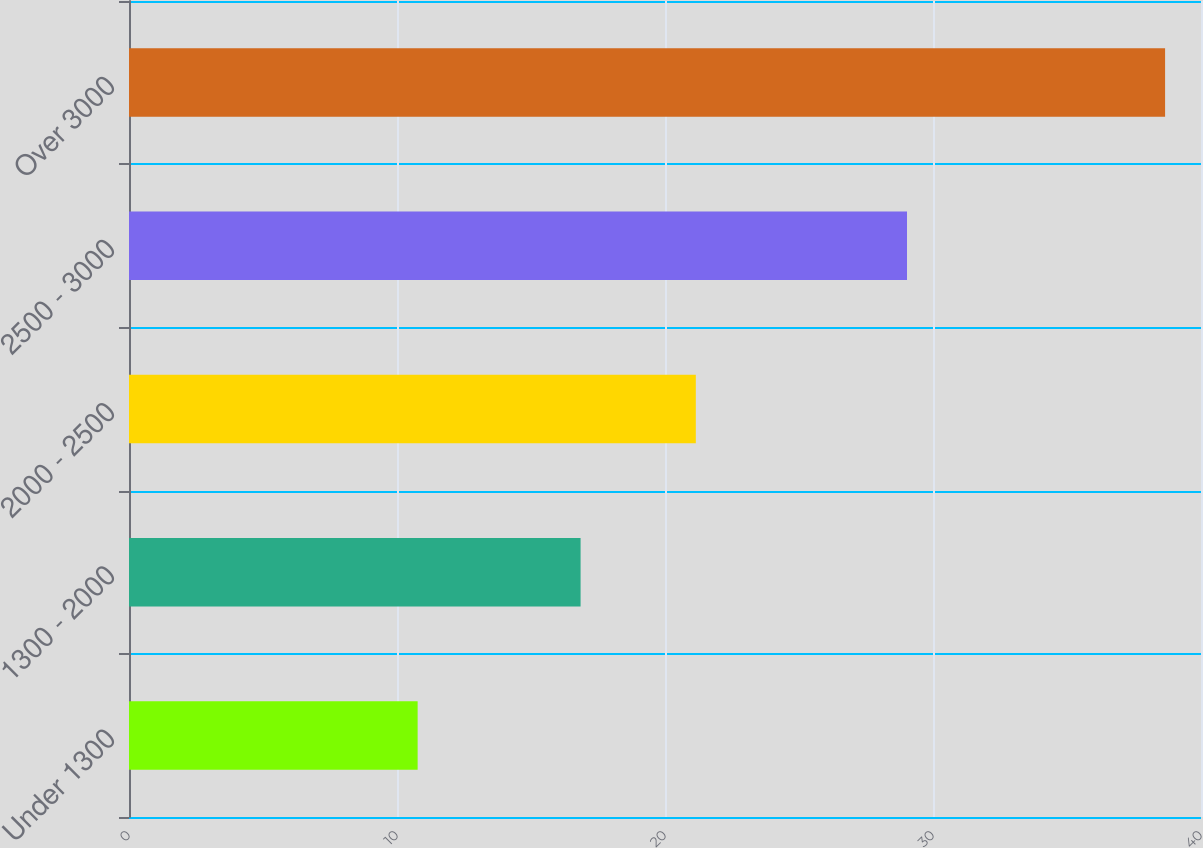<chart> <loc_0><loc_0><loc_500><loc_500><bar_chart><fcel>Under 1300<fcel>1300 - 2000<fcel>2000 - 2500<fcel>2500 - 3000<fcel>Over 3000<nl><fcel>10.77<fcel>16.85<fcel>21.15<fcel>29.03<fcel>38.66<nl></chart> 